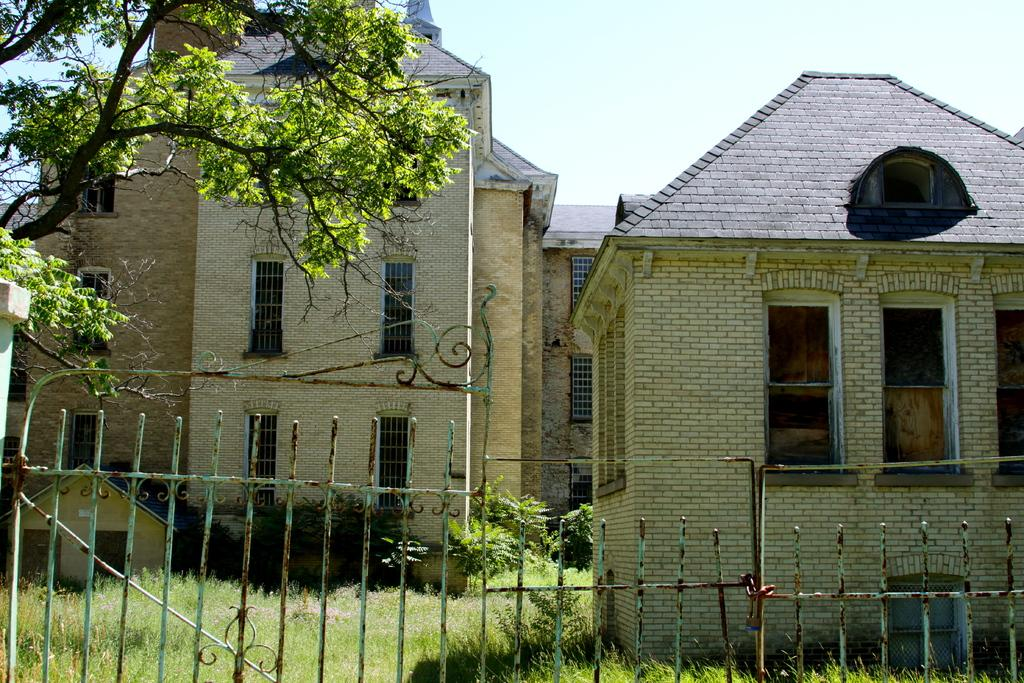What can be seen in the center of the image? The sky is visible in the center of the image. What type of structures are in the image? There are buildings in the image. What architectural feature is present in the image? Windows are present in the image. What type of vegetation is in the image? Plants and a tree with branches and leaves are in the image. What type of ground surface is visible in the image? Grass is visible in the image. What type of barrier is present in the image? A fence is present in the image. Can you see a goat walking on the sidewalk in the image? There is no goat or sidewalk present in the image. 